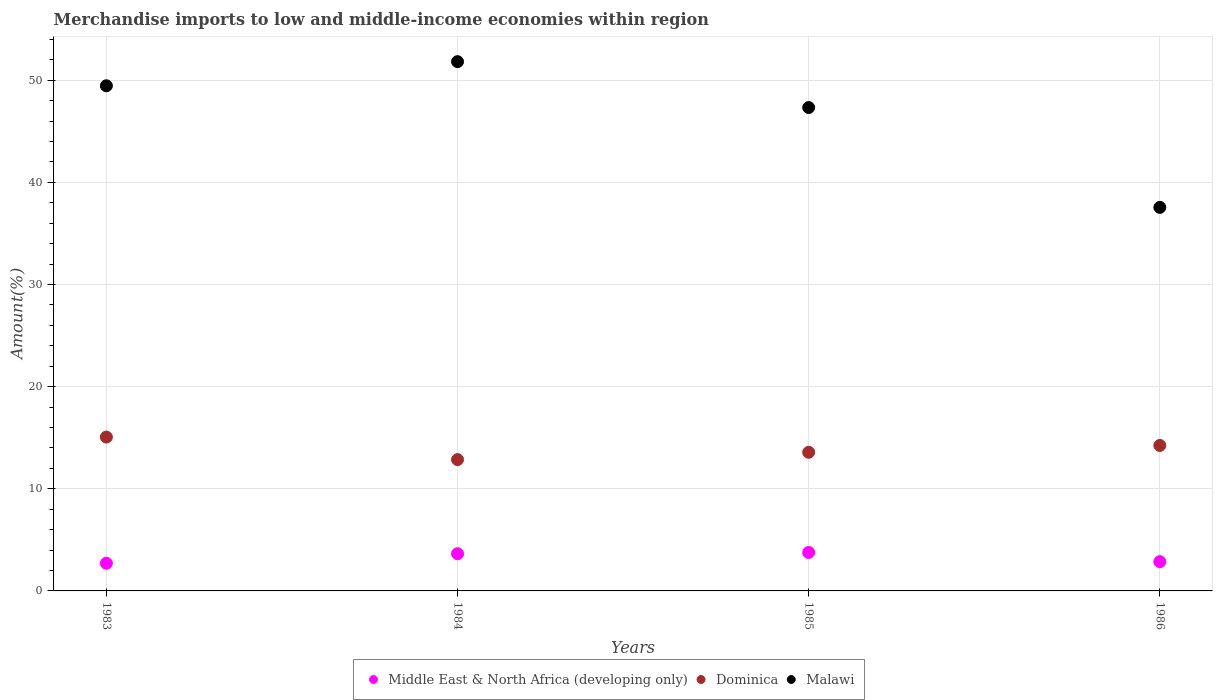How many different coloured dotlines are there?
Ensure brevity in your answer.  3. What is the percentage of amount earned from merchandise imports in Dominica in 1986?
Make the answer very short. 14.24. Across all years, what is the maximum percentage of amount earned from merchandise imports in Malawi?
Make the answer very short. 51.82. Across all years, what is the minimum percentage of amount earned from merchandise imports in Malawi?
Offer a terse response. 37.55. What is the total percentage of amount earned from merchandise imports in Dominica in the graph?
Your answer should be very brief. 55.74. What is the difference between the percentage of amount earned from merchandise imports in Dominica in 1984 and that in 1986?
Give a very brief answer. -1.39. What is the difference between the percentage of amount earned from merchandise imports in Dominica in 1983 and the percentage of amount earned from merchandise imports in Malawi in 1986?
Give a very brief answer. -22.49. What is the average percentage of amount earned from merchandise imports in Middle East & North Africa (developing only) per year?
Ensure brevity in your answer.  3.25. In the year 1984, what is the difference between the percentage of amount earned from merchandise imports in Dominica and percentage of amount earned from merchandise imports in Middle East & North Africa (developing only)?
Your response must be concise. 9.21. What is the ratio of the percentage of amount earned from merchandise imports in Middle East & North Africa (developing only) in 1984 to that in 1986?
Provide a short and direct response. 1.27. Is the difference between the percentage of amount earned from merchandise imports in Dominica in 1983 and 1986 greater than the difference between the percentage of amount earned from merchandise imports in Middle East & North Africa (developing only) in 1983 and 1986?
Your answer should be very brief. Yes. What is the difference between the highest and the second highest percentage of amount earned from merchandise imports in Malawi?
Make the answer very short. 2.36. What is the difference between the highest and the lowest percentage of amount earned from merchandise imports in Malawi?
Ensure brevity in your answer.  14.27. Is it the case that in every year, the sum of the percentage of amount earned from merchandise imports in Malawi and percentage of amount earned from merchandise imports in Dominica  is greater than the percentage of amount earned from merchandise imports in Middle East & North Africa (developing only)?
Keep it short and to the point. Yes. Does the percentage of amount earned from merchandise imports in Malawi monotonically increase over the years?
Keep it short and to the point. No. How many dotlines are there?
Offer a terse response. 3. How many years are there in the graph?
Provide a short and direct response. 4. Does the graph contain grids?
Provide a short and direct response. Yes. Where does the legend appear in the graph?
Your response must be concise. Bottom center. How many legend labels are there?
Make the answer very short. 3. What is the title of the graph?
Your response must be concise. Merchandise imports to low and middle-income economies within region. Does "Low & middle income" appear as one of the legend labels in the graph?
Your response must be concise. No. What is the label or title of the Y-axis?
Give a very brief answer. Amount(%). What is the Amount(%) of Middle East & North Africa (developing only) in 1983?
Make the answer very short. 2.71. What is the Amount(%) in Dominica in 1983?
Your answer should be very brief. 15.06. What is the Amount(%) in Malawi in 1983?
Ensure brevity in your answer.  49.46. What is the Amount(%) in Middle East & North Africa (developing only) in 1984?
Ensure brevity in your answer.  3.64. What is the Amount(%) of Dominica in 1984?
Make the answer very short. 12.86. What is the Amount(%) in Malawi in 1984?
Your answer should be compact. 51.82. What is the Amount(%) in Middle East & North Africa (developing only) in 1985?
Make the answer very short. 3.77. What is the Amount(%) in Dominica in 1985?
Your answer should be very brief. 13.57. What is the Amount(%) of Malawi in 1985?
Make the answer very short. 47.33. What is the Amount(%) of Middle East & North Africa (developing only) in 1986?
Your answer should be very brief. 2.86. What is the Amount(%) in Dominica in 1986?
Provide a short and direct response. 14.24. What is the Amount(%) of Malawi in 1986?
Offer a terse response. 37.55. Across all years, what is the maximum Amount(%) in Middle East & North Africa (developing only)?
Make the answer very short. 3.77. Across all years, what is the maximum Amount(%) in Dominica?
Offer a terse response. 15.06. Across all years, what is the maximum Amount(%) in Malawi?
Ensure brevity in your answer.  51.82. Across all years, what is the minimum Amount(%) in Middle East & North Africa (developing only)?
Offer a terse response. 2.71. Across all years, what is the minimum Amount(%) in Dominica?
Ensure brevity in your answer.  12.86. Across all years, what is the minimum Amount(%) of Malawi?
Ensure brevity in your answer.  37.55. What is the total Amount(%) in Middle East & North Africa (developing only) in the graph?
Offer a very short reply. 12.98. What is the total Amount(%) in Dominica in the graph?
Give a very brief answer. 55.74. What is the total Amount(%) of Malawi in the graph?
Give a very brief answer. 186.16. What is the difference between the Amount(%) in Middle East & North Africa (developing only) in 1983 and that in 1984?
Your answer should be compact. -0.93. What is the difference between the Amount(%) in Dominica in 1983 and that in 1984?
Give a very brief answer. 2.21. What is the difference between the Amount(%) in Malawi in 1983 and that in 1984?
Offer a very short reply. -2.36. What is the difference between the Amount(%) of Middle East & North Africa (developing only) in 1983 and that in 1985?
Make the answer very short. -1.06. What is the difference between the Amount(%) of Dominica in 1983 and that in 1985?
Provide a short and direct response. 1.49. What is the difference between the Amount(%) in Malawi in 1983 and that in 1985?
Make the answer very short. 2.13. What is the difference between the Amount(%) in Middle East & North Africa (developing only) in 1983 and that in 1986?
Your response must be concise. -0.15. What is the difference between the Amount(%) of Dominica in 1983 and that in 1986?
Give a very brief answer. 0.82. What is the difference between the Amount(%) of Malawi in 1983 and that in 1986?
Make the answer very short. 11.91. What is the difference between the Amount(%) of Middle East & North Africa (developing only) in 1984 and that in 1985?
Offer a very short reply. -0.12. What is the difference between the Amount(%) of Dominica in 1984 and that in 1985?
Your answer should be very brief. -0.72. What is the difference between the Amount(%) of Malawi in 1984 and that in 1985?
Offer a very short reply. 4.49. What is the difference between the Amount(%) of Middle East & North Africa (developing only) in 1984 and that in 1986?
Offer a very short reply. 0.78. What is the difference between the Amount(%) of Dominica in 1984 and that in 1986?
Give a very brief answer. -1.39. What is the difference between the Amount(%) in Malawi in 1984 and that in 1986?
Your answer should be compact. 14.27. What is the difference between the Amount(%) in Middle East & North Africa (developing only) in 1985 and that in 1986?
Give a very brief answer. 0.9. What is the difference between the Amount(%) in Dominica in 1985 and that in 1986?
Ensure brevity in your answer.  -0.67. What is the difference between the Amount(%) in Malawi in 1985 and that in 1986?
Provide a short and direct response. 9.77. What is the difference between the Amount(%) of Middle East & North Africa (developing only) in 1983 and the Amount(%) of Dominica in 1984?
Your answer should be very brief. -10.15. What is the difference between the Amount(%) in Middle East & North Africa (developing only) in 1983 and the Amount(%) in Malawi in 1984?
Your response must be concise. -49.11. What is the difference between the Amount(%) of Dominica in 1983 and the Amount(%) of Malawi in 1984?
Offer a very short reply. -36.76. What is the difference between the Amount(%) of Middle East & North Africa (developing only) in 1983 and the Amount(%) of Dominica in 1985?
Your answer should be compact. -10.86. What is the difference between the Amount(%) in Middle East & North Africa (developing only) in 1983 and the Amount(%) in Malawi in 1985?
Your answer should be very brief. -44.62. What is the difference between the Amount(%) in Dominica in 1983 and the Amount(%) in Malawi in 1985?
Offer a terse response. -32.26. What is the difference between the Amount(%) in Middle East & North Africa (developing only) in 1983 and the Amount(%) in Dominica in 1986?
Ensure brevity in your answer.  -11.53. What is the difference between the Amount(%) of Middle East & North Africa (developing only) in 1983 and the Amount(%) of Malawi in 1986?
Give a very brief answer. -34.84. What is the difference between the Amount(%) in Dominica in 1983 and the Amount(%) in Malawi in 1986?
Offer a terse response. -22.49. What is the difference between the Amount(%) in Middle East & North Africa (developing only) in 1984 and the Amount(%) in Dominica in 1985?
Your answer should be compact. -9.93. What is the difference between the Amount(%) of Middle East & North Africa (developing only) in 1984 and the Amount(%) of Malawi in 1985?
Provide a short and direct response. -43.69. What is the difference between the Amount(%) of Dominica in 1984 and the Amount(%) of Malawi in 1985?
Give a very brief answer. -34.47. What is the difference between the Amount(%) of Middle East & North Africa (developing only) in 1984 and the Amount(%) of Dominica in 1986?
Ensure brevity in your answer.  -10.6. What is the difference between the Amount(%) in Middle East & North Africa (developing only) in 1984 and the Amount(%) in Malawi in 1986?
Provide a succinct answer. -33.91. What is the difference between the Amount(%) of Dominica in 1984 and the Amount(%) of Malawi in 1986?
Offer a terse response. -24.7. What is the difference between the Amount(%) in Middle East & North Africa (developing only) in 1985 and the Amount(%) in Dominica in 1986?
Provide a succinct answer. -10.48. What is the difference between the Amount(%) of Middle East & North Africa (developing only) in 1985 and the Amount(%) of Malawi in 1986?
Offer a terse response. -33.79. What is the difference between the Amount(%) in Dominica in 1985 and the Amount(%) in Malawi in 1986?
Give a very brief answer. -23.98. What is the average Amount(%) of Middle East & North Africa (developing only) per year?
Your response must be concise. 3.25. What is the average Amount(%) in Dominica per year?
Your response must be concise. 13.93. What is the average Amount(%) of Malawi per year?
Ensure brevity in your answer.  46.54. In the year 1983, what is the difference between the Amount(%) in Middle East & North Africa (developing only) and Amount(%) in Dominica?
Provide a short and direct response. -12.35. In the year 1983, what is the difference between the Amount(%) in Middle East & North Africa (developing only) and Amount(%) in Malawi?
Provide a succinct answer. -46.75. In the year 1983, what is the difference between the Amount(%) of Dominica and Amount(%) of Malawi?
Your answer should be very brief. -34.4. In the year 1984, what is the difference between the Amount(%) of Middle East & North Africa (developing only) and Amount(%) of Dominica?
Your response must be concise. -9.21. In the year 1984, what is the difference between the Amount(%) in Middle East & North Africa (developing only) and Amount(%) in Malawi?
Ensure brevity in your answer.  -48.18. In the year 1984, what is the difference between the Amount(%) in Dominica and Amount(%) in Malawi?
Provide a succinct answer. -38.96. In the year 1985, what is the difference between the Amount(%) of Middle East & North Africa (developing only) and Amount(%) of Dominica?
Make the answer very short. -9.81. In the year 1985, what is the difference between the Amount(%) of Middle East & North Africa (developing only) and Amount(%) of Malawi?
Offer a very short reply. -43.56. In the year 1985, what is the difference between the Amount(%) of Dominica and Amount(%) of Malawi?
Provide a succinct answer. -33.75. In the year 1986, what is the difference between the Amount(%) of Middle East & North Africa (developing only) and Amount(%) of Dominica?
Make the answer very short. -11.38. In the year 1986, what is the difference between the Amount(%) in Middle East & North Africa (developing only) and Amount(%) in Malawi?
Provide a short and direct response. -34.69. In the year 1986, what is the difference between the Amount(%) of Dominica and Amount(%) of Malawi?
Make the answer very short. -23.31. What is the ratio of the Amount(%) in Middle East & North Africa (developing only) in 1983 to that in 1984?
Provide a short and direct response. 0.74. What is the ratio of the Amount(%) in Dominica in 1983 to that in 1984?
Your response must be concise. 1.17. What is the ratio of the Amount(%) of Malawi in 1983 to that in 1984?
Offer a terse response. 0.95. What is the ratio of the Amount(%) of Middle East & North Africa (developing only) in 1983 to that in 1985?
Offer a very short reply. 0.72. What is the ratio of the Amount(%) in Dominica in 1983 to that in 1985?
Make the answer very short. 1.11. What is the ratio of the Amount(%) in Malawi in 1983 to that in 1985?
Offer a terse response. 1.04. What is the ratio of the Amount(%) in Middle East & North Africa (developing only) in 1983 to that in 1986?
Your answer should be compact. 0.95. What is the ratio of the Amount(%) in Dominica in 1983 to that in 1986?
Your answer should be compact. 1.06. What is the ratio of the Amount(%) in Malawi in 1983 to that in 1986?
Offer a very short reply. 1.32. What is the ratio of the Amount(%) in Dominica in 1984 to that in 1985?
Ensure brevity in your answer.  0.95. What is the ratio of the Amount(%) of Malawi in 1984 to that in 1985?
Provide a succinct answer. 1.09. What is the ratio of the Amount(%) of Middle East & North Africa (developing only) in 1984 to that in 1986?
Offer a very short reply. 1.27. What is the ratio of the Amount(%) in Dominica in 1984 to that in 1986?
Make the answer very short. 0.9. What is the ratio of the Amount(%) of Malawi in 1984 to that in 1986?
Provide a short and direct response. 1.38. What is the ratio of the Amount(%) in Middle East & North Africa (developing only) in 1985 to that in 1986?
Ensure brevity in your answer.  1.32. What is the ratio of the Amount(%) in Dominica in 1985 to that in 1986?
Your answer should be compact. 0.95. What is the ratio of the Amount(%) of Malawi in 1985 to that in 1986?
Provide a succinct answer. 1.26. What is the difference between the highest and the second highest Amount(%) of Middle East & North Africa (developing only)?
Provide a short and direct response. 0.12. What is the difference between the highest and the second highest Amount(%) in Dominica?
Your response must be concise. 0.82. What is the difference between the highest and the second highest Amount(%) in Malawi?
Your answer should be very brief. 2.36. What is the difference between the highest and the lowest Amount(%) in Middle East & North Africa (developing only)?
Provide a succinct answer. 1.06. What is the difference between the highest and the lowest Amount(%) of Dominica?
Provide a succinct answer. 2.21. What is the difference between the highest and the lowest Amount(%) of Malawi?
Offer a terse response. 14.27. 